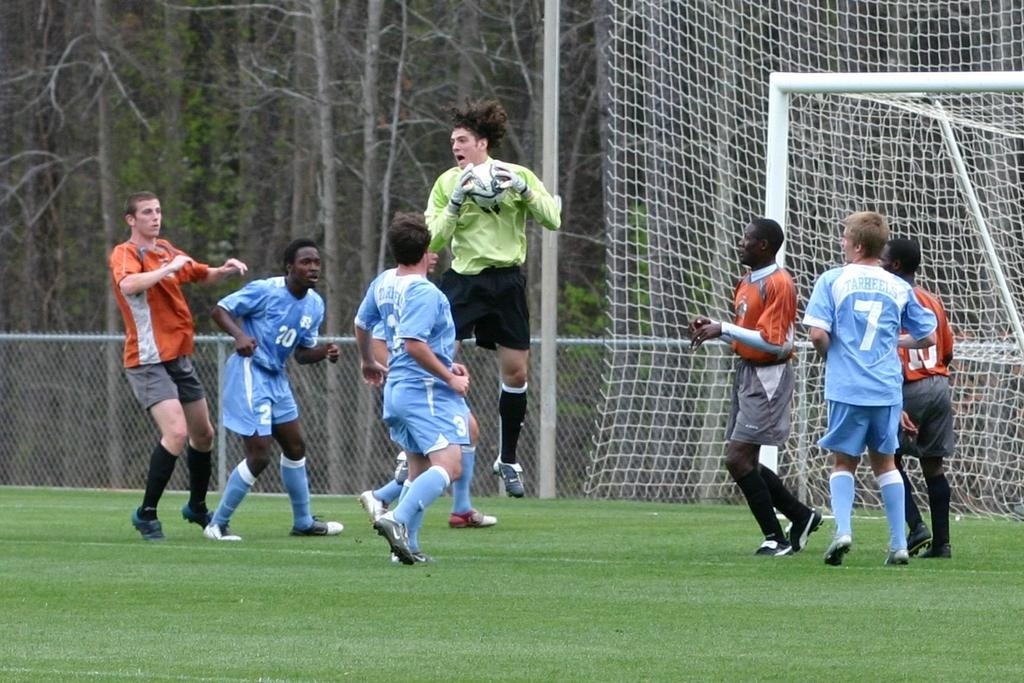What activity are the men in the image engaged in? The men are playing football in the image. Where is the football game taking place? The football game is taking place on a green field. What can be seen in the background of the image? There are trees visible around the field. What type of knife is being used by the men to play football in the image? There is no knife present in the image; the men are playing football using a football. 